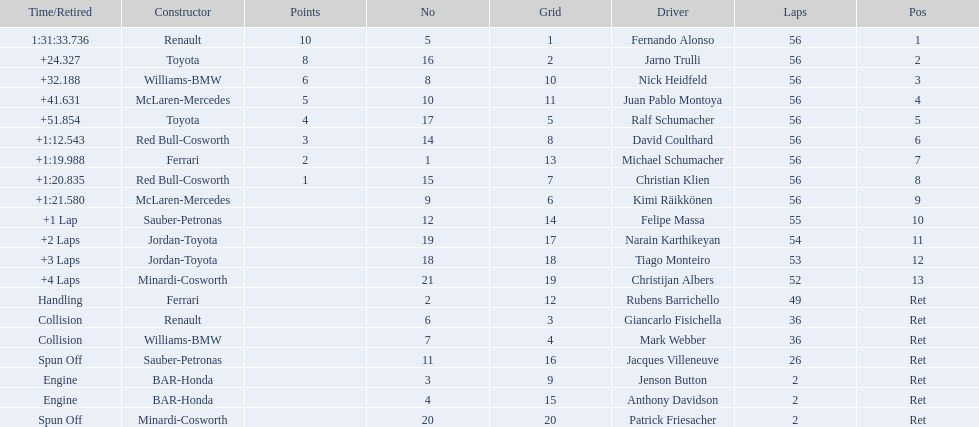Who raced during the 2005 malaysian grand prix? Fernando Alonso, Jarno Trulli, Nick Heidfeld, Juan Pablo Montoya, Ralf Schumacher, David Coulthard, Michael Schumacher, Christian Klien, Kimi Räikkönen, Felipe Massa, Narain Karthikeyan, Tiago Monteiro, Christijan Albers, Rubens Barrichello, Giancarlo Fisichella, Mark Webber, Jacques Villeneuve, Jenson Button, Anthony Davidson, Patrick Friesacher. What were their finishing times? 1:31:33.736, +24.327, +32.188, +41.631, +51.854, +1:12.543, +1:19.988, +1:20.835, +1:21.580, +1 Lap, +2 Laps, +3 Laps, +4 Laps, Handling, Collision, Collision, Spun Off, Engine, Engine, Spun Off. What was fernando alonso's finishing time? 1:31:33.736. 